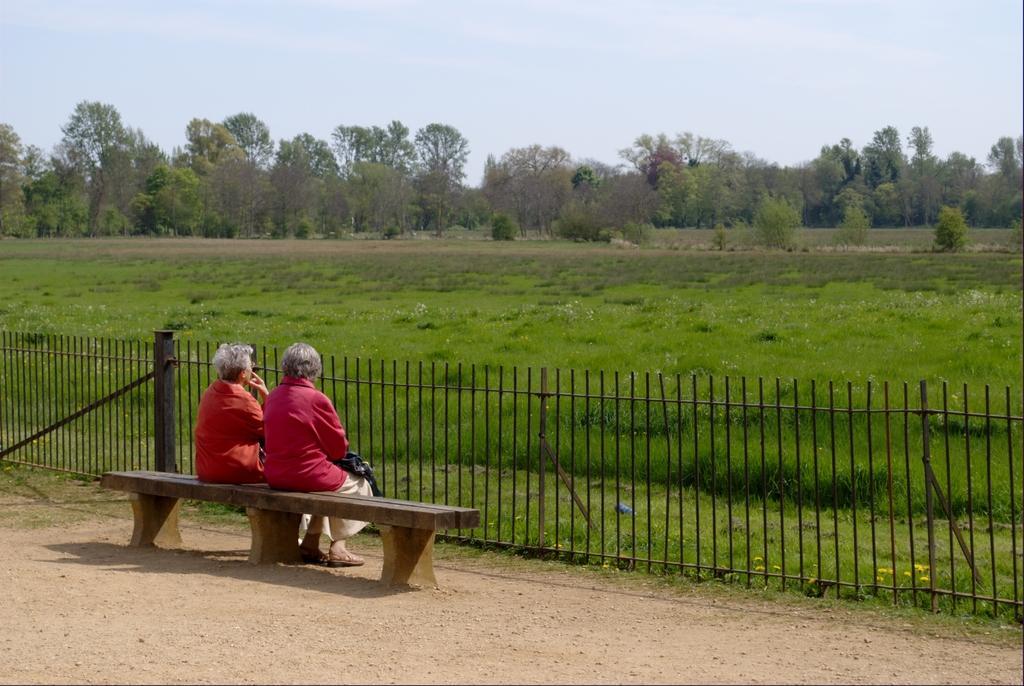Please provide a concise description of this image. In this picture we can see two persons sitting on the bench. This is grass and there is a fence. Here we can see some yellow colored flowers. And on the background there are many trees. And this is the sky. 